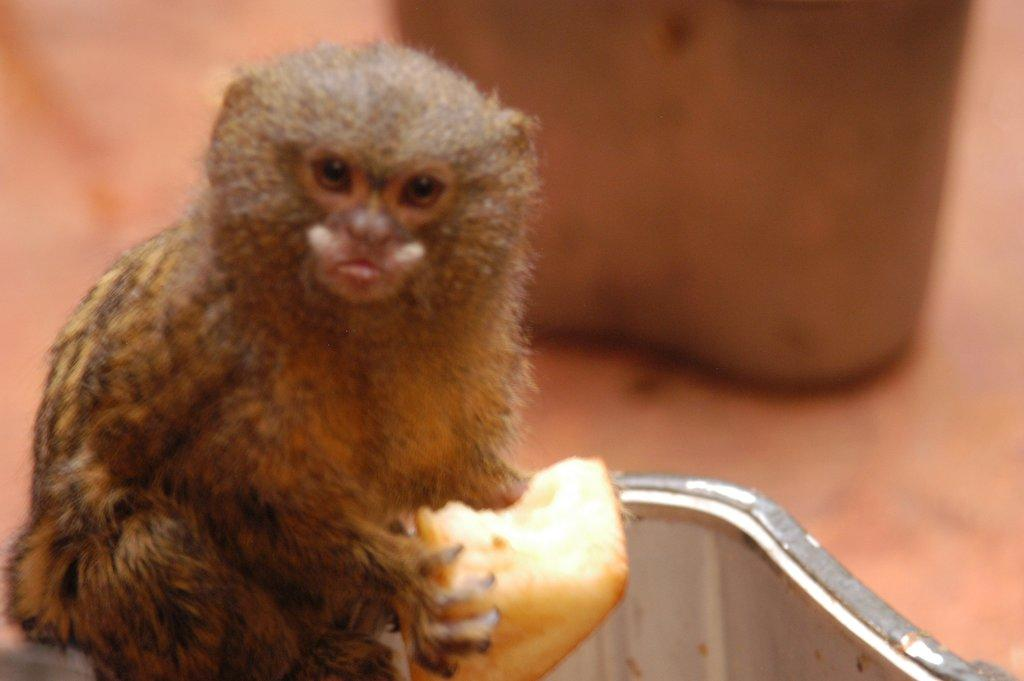What type of creature is present in the image? There is an animal in the image. What is the animal doing in the image? The animal is holding something in its hand. Can you describe the background of the image? The background of the image is blurred. Is there a mailbox visible in the image? There is no mention of a mailbox in the provided facts, so it cannot be determined if one is present in the image. What type of view can be seen from the animal's perspective in the image? The provided facts do not give any information about the animal's perspective or the view it might have, so it cannot be determined. 